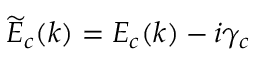Convert formula to latex. <formula><loc_0><loc_0><loc_500><loc_500>\widetilde { E } _ { c } ( k ) = E _ { c } ( k ) - i \gamma _ { c }</formula> 